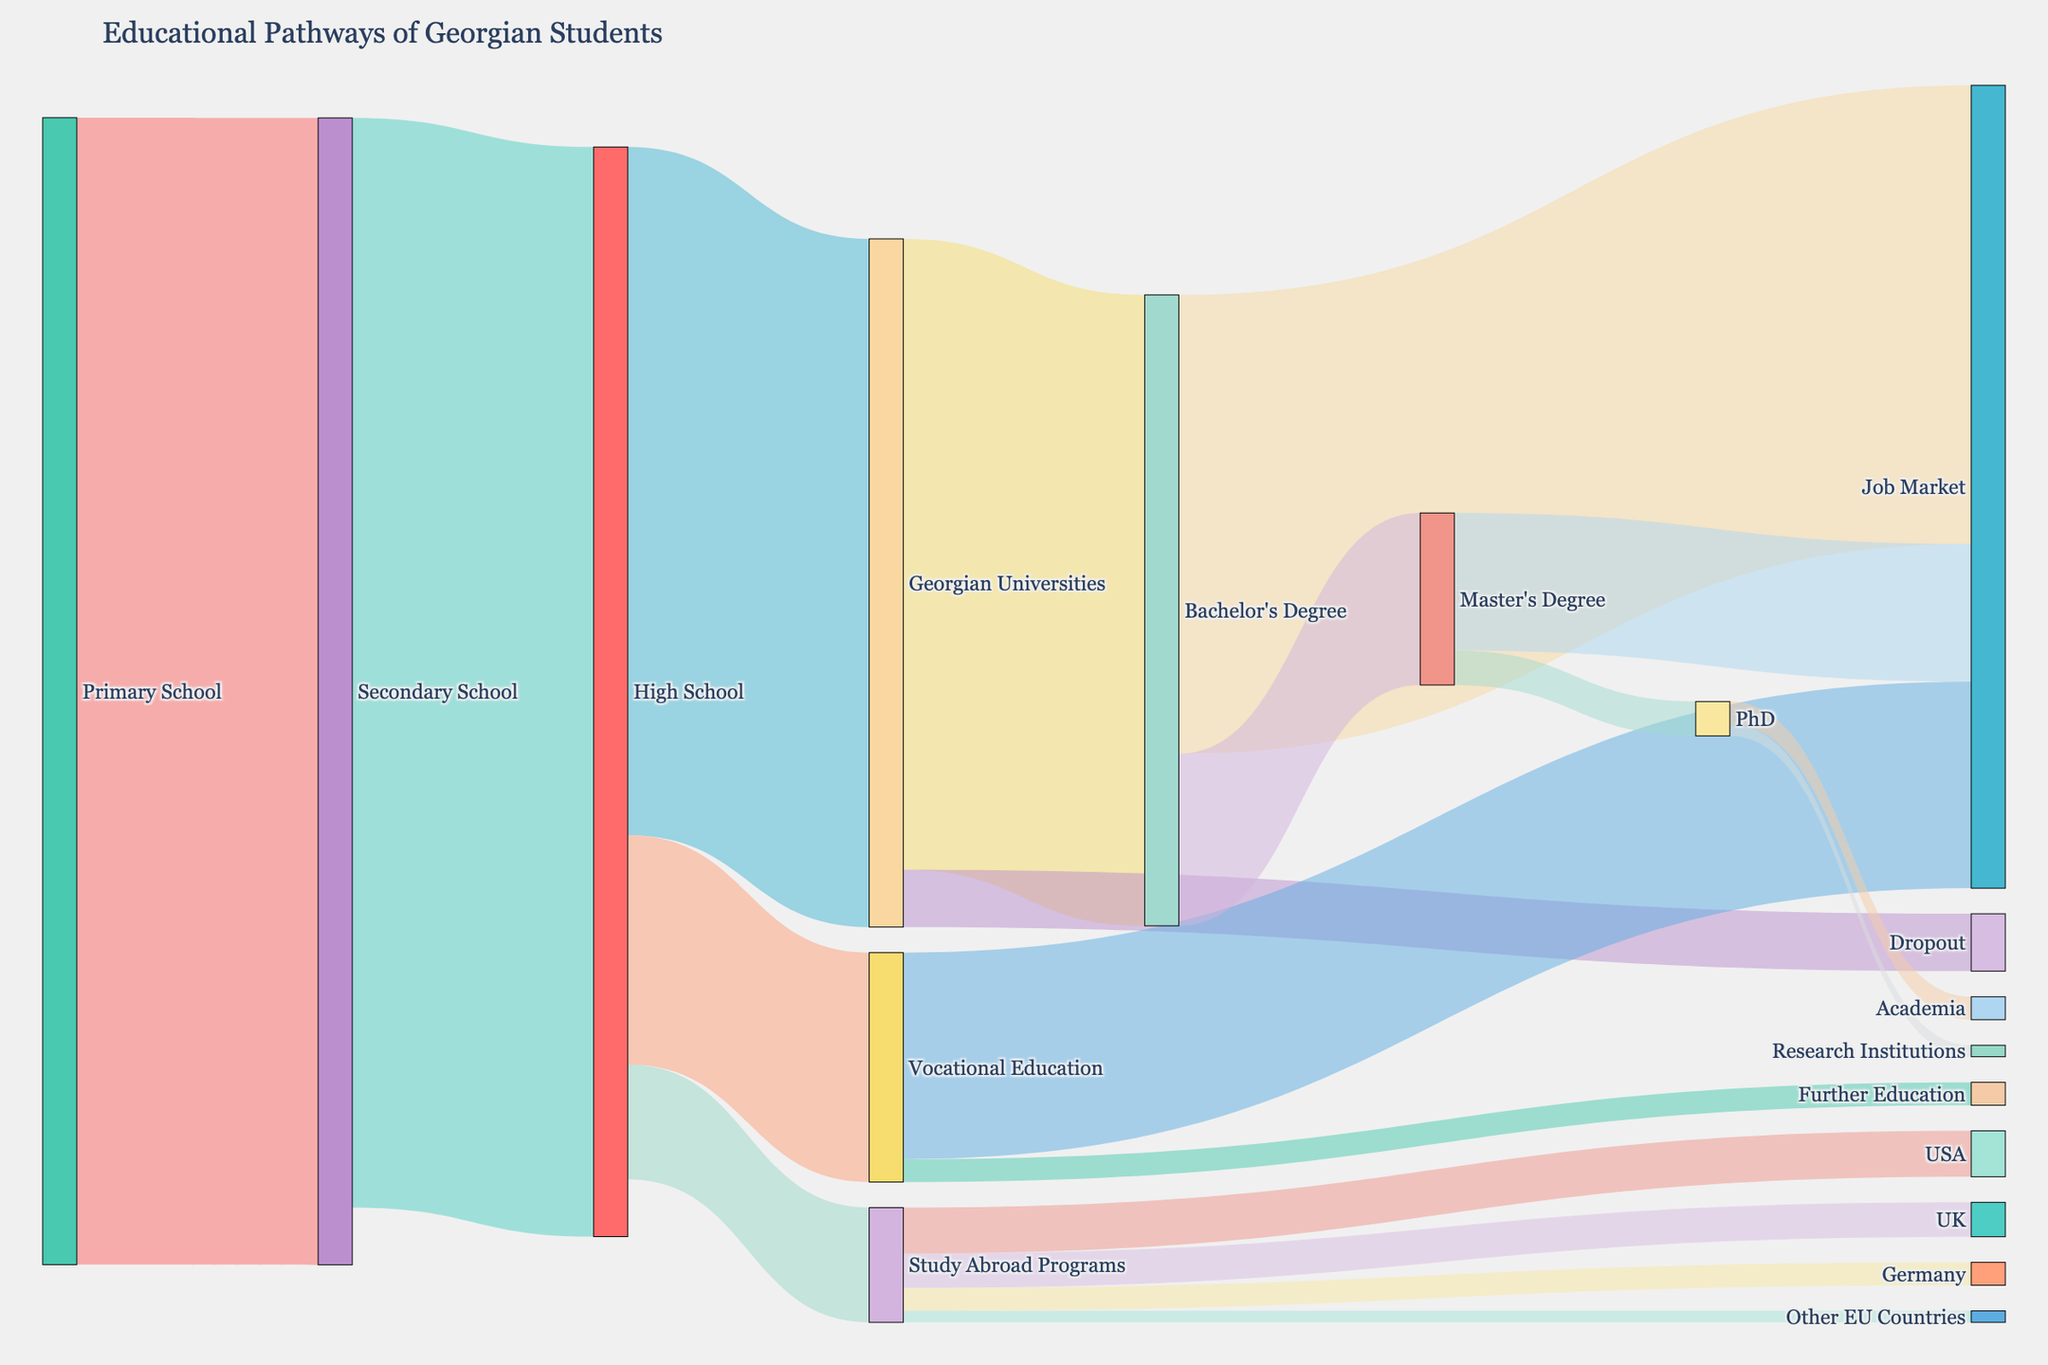How many students complete primary school and move to secondary school? To find the number of students who complete primary school and move to secondary school, refer to the connection between "Primary School" and "Secondary School" in the diagram. The value given for this link is 100,000.
Answer: 100,000 What is the total number of students who transition from high school to higher education pathways? To find this, sum the values of the links from "High School" to "Georgian Universities", "Vocational Education", and "Study Abroad Programs". These values are 60,000, 20,000, and 10,000, respectively, giving a total of 60,000 + 20,000 + 10,000 = 90,000 students.
Answer: 90,000 How many students in total move from vocational education to their next steps? Sum the values of the links from "Vocational Education" to "Job Market" and "Further Education". These values are 18,000 and 2,000, respectively, giving a total of 18,000 + 2,000 = 20,000 students.
Answer: 20,000 Which destination has the smallest number of students from study abroad programs? Check the values of the links from "Study Abroad Programs" to different countries. The smallest value is for "Other EU Countries" which is 1,000 students.
Answer: Other EU Countries What percentage of students who pursue a Bachelor's degree enter the job market after graduation? First, identify the total number of students who complete a Bachelor's degree, which is 55,000. Then, find the number of students who enter the job market, which is 40,000. The percentage is (40,000 / 55,000) * 100% = 72.73%.
Answer: 72.73% How many students continue their education after obtaining a Master's degree? Check the value of the link from "Master's Degree" to "PhD". The number is 3,000.
Answer: 3,000 Compare the number of students who drop out from Georgian universities with those who move to the job market after completing their Bachelor's degree. The number of students who drop out is 5,000, and those who enter the job market after obtaining a Bachelor's degree is 40,000. 5,000 is significantly smaller than 40,000.
Answer: 5,000 is less than 40,000 What is the combined total of students who pursue higher education abroad in the USA, UK, and Germany? Sum the values of the links to the USA, UK, and Germany. These values are 4,000, 3,000, and 2,000, respectively, giving a total of 4,000 + 3,000 + 2,000 = 9,000 students.
Answer: 9,000 Which pathway has the highest number of students transitioning through it? The pathway from "Secondary School" to "High School" has the highest number, with 95,000 students.
Answer: Secondary School to High School What proportion of students from Georgian universities drop out before completing their Bachelor's degree? Identify the number of students who drop out, which is 5,000, and the total students from Georgian universities, which is 60,000 (students who pursue Bachelor's degree or drop out). The proportion is 5,000 / 60,000 = 0.0833, or 8.33%.
Answer: 8.33% 